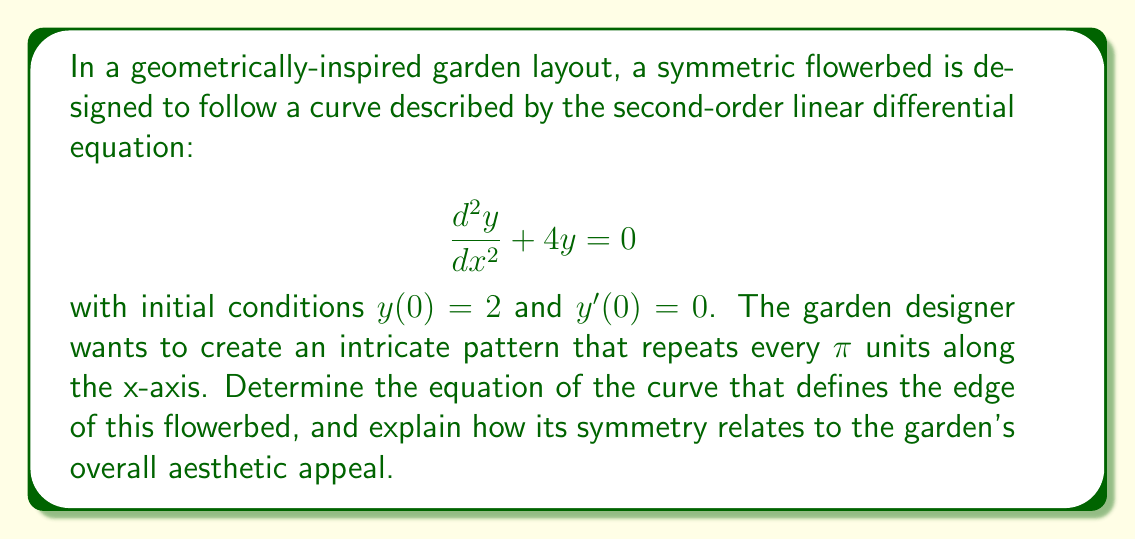Can you answer this question? To solve this problem, we'll follow these steps:

1) The given differential equation is a homogeneous linear equation of the second order. Its characteristic equation is:

   $$r^2 + 4 = 0$$

2) Solving this equation:
   $$r = \pm 2i$$

3) The general solution to this differential equation is:

   $$y = C_1 \cos(2x) + C_2 \sin(2x)$$

4) Now we use the initial conditions to find $C_1$ and $C_2$:

   At $x = 0$: $y(0) = 2$, so $C_1 = 2$

   For $y'(0) = 0$:
   $$y' = -2C_1 \sin(2x) + 2C_2 \cos(2x)$$
   $$0 = 2C_2$$
   So $C_2 = 0$

5) Therefore, the particular solution is:

   $$y = 2 \cos(2x)$$

6) This function has a period of $\pi$, which satisfies the designer's requirement for the pattern to repeat every $\pi$ units along the x-axis.

7) The symmetry of this curve is evident in its properties:
   - It's an even function, symmetric about the y-axis
   - It repeats every $\pi$ units along the x-axis
   - It oscillates between -2 and 2 on the y-axis

This symmetry contributes to the garden's aesthetic appeal by creating a balanced, rhythmic pattern. The cosine function produces smooth, undulating curves that can be visually pleasing in a garden setting. The repetition every $\pi$ units allows for a consistent design that can be extended throughout the garden space, creating a sense of harmony and order that's often appreciated in formal garden designs.
Answer: The equation of the curve defining the edge of the flowerbed is $y = 2 \cos(2x)$. 